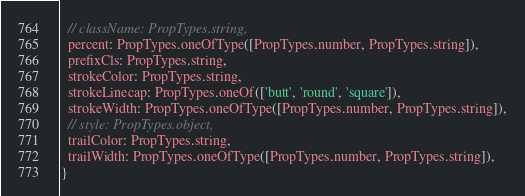<code> <loc_0><loc_0><loc_500><loc_500><_JavaScript_>  // className: PropTypes.string,
  percent: PropTypes.oneOfType([PropTypes.number, PropTypes.string]),
  prefixCls: PropTypes.string,
  strokeColor: PropTypes.string,
  strokeLinecap: PropTypes.oneOf(['butt', 'round', 'square']),
  strokeWidth: PropTypes.oneOfType([PropTypes.number, PropTypes.string]),
  // style: PropTypes.object,
  trailColor: PropTypes.string,
  trailWidth: PropTypes.oneOfType([PropTypes.number, PropTypes.string]),
}
</code> 